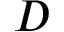<formula> <loc_0><loc_0><loc_500><loc_500>D</formula> 